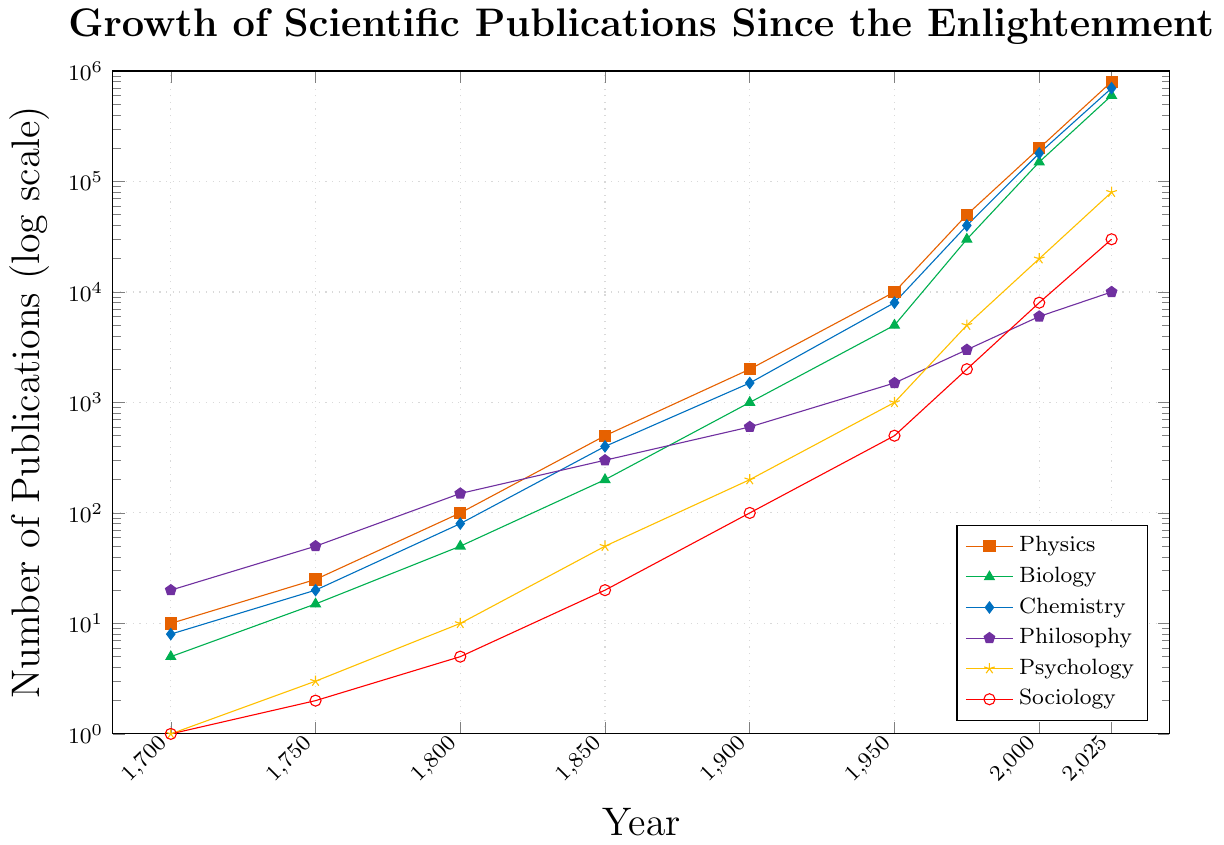What discipline has the highest number of publications in 2025? By examining the end of each line representing different disciplines on the logscale, the highest point denotes the largest number of publications. Physics reaches 800,000 publications in 2025, the highest among all listed disciplines.
Answer: Physics Which discipline had more publications in 1850, Philosophy or Biology? To determine which had more, compare the y-values for Philosophy and Biology at 1850. Philosophy had 300 publications, while Biology had 200 publications in 1850.
Answer: Philosophy What's the difference in the number of publications between Biology and Sociology in the year 2000? In 2000, Biology had 150,000 publications, and Sociology had 8,000. The difference is calculated by subtracting the number of Sociology publications from Biology publications: 150,000 - 8,000 = 142,000.
Answer: 142,000 Has Psychology or Chemistry shown a faster growth rate between 1950 and 2000? Compare the growth rates by looking at the number of publications in these years. Psychology grew from 1,000 to 20,000, a 20-fold increase. Chemistry grew from 8,000 to 180,000, a 22.5-fold increase. Hence, Chemistry shows a faster growth rate over this period.
Answer: Chemistry Which discipline had the slowest growth from 1750 to 1800? Calculate the growth for each discipline from 1750 to 1800, then determine which has the smallest increase:
Physics grew from 25 to 100 (+75),
Biology from 15 to 50 (+35),
Chemistry from 20 to 80 (+60),
Philosophy from 50 to 150 (+100),
Psychology from 3 to 10 (+7),
Sociology from 2 to 5 (+3).
Therefore, Sociology had the slowest growth.
Answer: Sociology What is the median number of publications in 1950 for all disciplines combined? First, list the values: Physics (10,000), Biology (5,000), Chemistry (8,000), Philosophy (1,500), Psychology (1,000), Sociology (500). Ordering these: 500, 1,000, 1,500, 5,000, 8,000, 10,000. The median is the average of the third and fourth values: (1,500 + 5,000) / 2 = 3,250.
Answer: 3,250 By approximately how many times did Philosophy publications increase from 1800 to 1950? Philosophical publications were 150 in 1800 and 1,500 in 1950. The increase is by a factor of 1,500 / 150 = 10 times.
Answer: 10 times Did Sociology surpass Philosophy in publication numbers at any point between 1700 and 2025? Observing the entire timeline, Psychology never surpasses Philosophy as the line for Philosophy remains higher than Sociology at every plotted point from 1700 to 2025.
Answer: No How did the number of Chemistry publications in 1900 compare with those in 1850? Chemistry publications in 1900 were 1,500, compared with 400 in 1850. This reflects an increase of 1,500 - 400 = 1,100 publications.
Answer: 1,100 more Which colors correspond to Psychology and Biology? Referring to the visual color keys, Psychology is represented in yellow and Biology in green.
Answer: yellow and green 